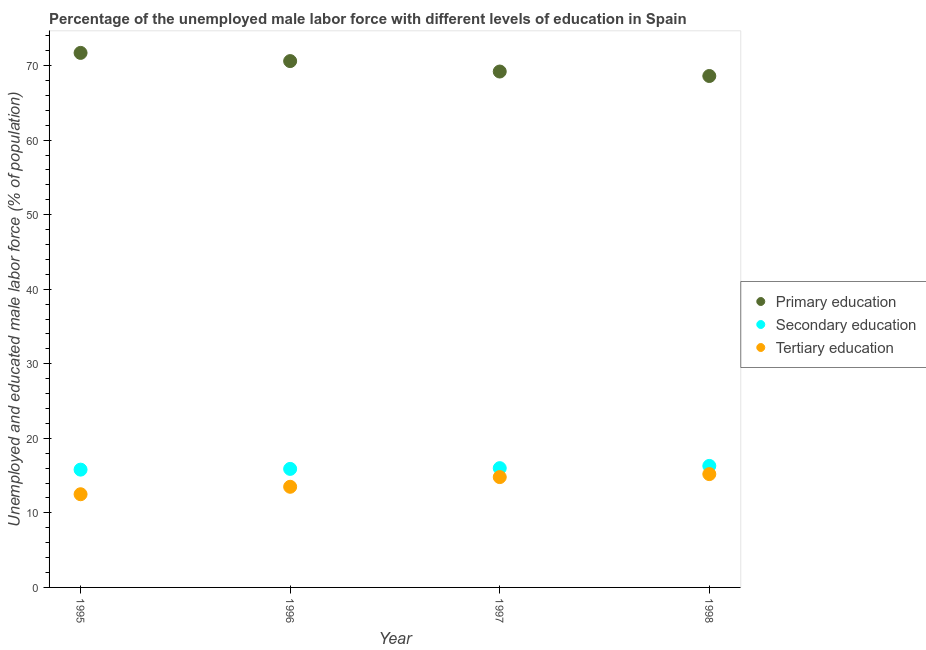How many different coloured dotlines are there?
Your response must be concise. 3. Is the number of dotlines equal to the number of legend labels?
Provide a short and direct response. Yes. What is the percentage of male labor force who received secondary education in 1996?
Give a very brief answer. 15.9. Across all years, what is the maximum percentage of male labor force who received primary education?
Give a very brief answer. 71.7. Across all years, what is the minimum percentage of male labor force who received secondary education?
Provide a succinct answer. 15.8. In which year was the percentage of male labor force who received secondary education maximum?
Provide a short and direct response. 1998. In which year was the percentage of male labor force who received primary education minimum?
Ensure brevity in your answer.  1998. What is the total percentage of male labor force who received tertiary education in the graph?
Keep it short and to the point. 56. What is the difference between the percentage of male labor force who received secondary education in 1996 and that in 1998?
Your answer should be very brief. -0.4. What is the difference between the percentage of male labor force who received tertiary education in 1997 and the percentage of male labor force who received secondary education in 1996?
Give a very brief answer. -1.1. What is the average percentage of male labor force who received secondary education per year?
Your answer should be compact. 16. In the year 1997, what is the difference between the percentage of male labor force who received primary education and percentage of male labor force who received secondary education?
Keep it short and to the point. 53.2. In how many years, is the percentage of male labor force who received primary education greater than 28 %?
Offer a very short reply. 4. What is the ratio of the percentage of male labor force who received primary education in 1995 to that in 1998?
Your response must be concise. 1.05. Is the percentage of male labor force who received secondary education in 1997 less than that in 1998?
Ensure brevity in your answer.  Yes. What is the difference between the highest and the second highest percentage of male labor force who received primary education?
Your response must be concise. 1.1. What is the difference between the highest and the lowest percentage of male labor force who received tertiary education?
Your answer should be very brief. 2.7. In how many years, is the percentage of male labor force who received tertiary education greater than the average percentage of male labor force who received tertiary education taken over all years?
Offer a terse response. 2. Is it the case that in every year, the sum of the percentage of male labor force who received primary education and percentage of male labor force who received secondary education is greater than the percentage of male labor force who received tertiary education?
Make the answer very short. Yes. Does the percentage of male labor force who received tertiary education monotonically increase over the years?
Ensure brevity in your answer.  Yes. Are the values on the major ticks of Y-axis written in scientific E-notation?
Your answer should be compact. No. Does the graph contain grids?
Offer a terse response. No. How are the legend labels stacked?
Offer a terse response. Vertical. What is the title of the graph?
Keep it short and to the point. Percentage of the unemployed male labor force with different levels of education in Spain. Does "Other sectors" appear as one of the legend labels in the graph?
Provide a short and direct response. No. What is the label or title of the Y-axis?
Make the answer very short. Unemployed and educated male labor force (% of population). What is the Unemployed and educated male labor force (% of population) of Primary education in 1995?
Provide a short and direct response. 71.7. What is the Unemployed and educated male labor force (% of population) in Secondary education in 1995?
Your answer should be compact. 15.8. What is the Unemployed and educated male labor force (% of population) in Primary education in 1996?
Your answer should be compact. 70.6. What is the Unemployed and educated male labor force (% of population) in Secondary education in 1996?
Your answer should be very brief. 15.9. What is the Unemployed and educated male labor force (% of population) in Primary education in 1997?
Ensure brevity in your answer.  69.2. What is the Unemployed and educated male labor force (% of population) in Secondary education in 1997?
Ensure brevity in your answer.  16. What is the Unemployed and educated male labor force (% of population) of Tertiary education in 1997?
Your answer should be very brief. 14.8. What is the Unemployed and educated male labor force (% of population) of Primary education in 1998?
Ensure brevity in your answer.  68.6. What is the Unemployed and educated male labor force (% of population) in Secondary education in 1998?
Make the answer very short. 16.3. What is the Unemployed and educated male labor force (% of population) in Tertiary education in 1998?
Offer a very short reply. 15.2. Across all years, what is the maximum Unemployed and educated male labor force (% of population) of Primary education?
Ensure brevity in your answer.  71.7. Across all years, what is the maximum Unemployed and educated male labor force (% of population) in Secondary education?
Your answer should be compact. 16.3. Across all years, what is the maximum Unemployed and educated male labor force (% of population) of Tertiary education?
Your response must be concise. 15.2. Across all years, what is the minimum Unemployed and educated male labor force (% of population) in Primary education?
Provide a short and direct response. 68.6. Across all years, what is the minimum Unemployed and educated male labor force (% of population) in Secondary education?
Keep it short and to the point. 15.8. Across all years, what is the minimum Unemployed and educated male labor force (% of population) of Tertiary education?
Your answer should be compact. 12.5. What is the total Unemployed and educated male labor force (% of population) of Primary education in the graph?
Offer a terse response. 280.1. What is the total Unemployed and educated male labor force (% of population) in Tertiary education in the graph?
Make the answer very short. 56. What is the difference between the Unemployed and educated male labor force (% of population) in Primary education in 1995 and that in 1996?
Keep it short and to the point. 1.1. What is the difference between the Unemployed and educated male labor force (% of population) of Primary education in 1995 and that in 1997?
Offer a terse response. 2.5. What is the difference between the Unemployed and educated male labor force (% of population) in Primary education in 1996 and that in 1998?
Give a very brief answer. 2. What is the difference between the Unemployed and educated male labor force (% of population) of Tertiary education in 1996 and that in 1998?
Make the answer very short. -1.7. What is the difference between the Unemployed and educated male labor force (% of population) of Tertiary education in 1997 and that in 1998?
Offer a terse response. -0.4. What is the difference between the Unemployed and educated male labor force (% of population) of Primary education in 1995 and the Unemployed and educated male labor force (% of population) of Secondary education in 1996?
Offer a terse response. 55.8. What is the difference between the Unemployed and educated male labor force (% of population) of Primary education in 1995 and the Unemployed and educated male labor force (% of population) of Tertiary education in 1996?
Provide a succinct answer. 58.2. What is the difference between the Unemployed and educated male labor force (% of population) of Primary education in 1995 and the Unemployed and educated male labor force (% of population) of Secondary education in 1997?
Make the answer very short. 55.7. What is the difference between the Unemployed and educated male labor force (% of population) of Primary education in 1995 and the Unemployed and educated male labor force (% of population) of Tertiary education in 1997?
Provide a short and direct response. 56.9. What is the difference between the Unemployed and educated male labor force (% of population) in Secondary education in 1995 and the Unemployed and educated male labor force (% of population) in Tertiary education in 1997?
Offer a terse response. 1. What is the difference between the Unemployed and educated male labor force (% of population) of Primary education in 1995 and the Unemployed and educated male labor force (% of population) of Secondary education in 1998?
Give a very brief answer. 55.4. What is the difference between the Unemployed and educated male labor force (% of population) in Primary education in 1995 and the Unemployed and educated male labor force (% of population) in Tertiary education in 1998?
Make the answer very short. 56.5. What is the difference between the Unemployed and educated male labor force (% of population) of Primary education in 1996 and the Unemployed and educated male labor force (% of population) of Secondary education in 1997?
Ensure brevity in your answer.  54.6. What is the difference between the Unemployed and educated male labor force (% of population) in Primary education in 1996 and the Unemployed and educated male labor force (% of population) in Tertiary education in 1997?
Your answer should be compact. 55.8. What is the difference between the Unemployed and educated male labor force (% of population) in Secondary education in 1996 and the Unemployed and educated male labor force (% of population) in Tertiary education in 1997?
Provide a short and direct response. 1.1. What is the difference between the Unemployed and educated male labor force (% of population) in Primary education in 1996 and the Unemployed and educated male labor force (% of population) in Secondary education in 1998?
Offer a very short reply. 54.3. What is the difference between the Unemployed and educated male labor force (% of population) of Primary education in 1996 and the Unemployed and educated male labor force (% of population) of Tertiary education in 1998?
Make the answer very short. 55.4. What is the difference between the Unemployed and educated male labor force (% of population) of Primary education in 1997 and the Unemployed and educated male labor force (% of population) of Secondary education in 1998?
Your answer should be compact. 52.9. What is the difference between the Unemployed and educated male labor force (% of population) in Primary education in 1997 and the Unemployed and educated male labor force (% of population) in Tertiary education in 1998?
Provide a short and direct response. 54. What is the difference between the Unemployed and educated male labor force (% of population) in Secondary education in 1997 and the Unemployed and educated male labor force (% of population) in Tertiary education in 1998?
Your answer should be compact. 0.8. What is the average Unemployed and educated male labor force (% of population) of Primary education per year?
Give a very brief answer. 70.03. What is the average Unemployed and educated male labor force (% of population) of Tertiary education per year?
Make the answer very short. 14. In the year 1995, what is the difference between the Unemployed and educated male labor force (% of population) of Primary education and Unemployed and educated male labor force (% of population) of Secondary education?
Offer a very short reply. 55.9. In the year 1995, what is the difference between the Unemployed and educated male labor force (% of population) of Primary education and Unemployed and educated male labor force (% of population) of Tertiary education?
Make the answer very short. 59.2. In the year 1996, what is the difference between the Unemployed and educated male labor force (% of population) of Primary education and Unemployed and educated male labor force (% of population) of Secondary education?
Your answer should be very brief. 54.7. In the year 1996, what is the difference between the Unemployed and educated male labor force (% of population) of Primary education and Unemployed and educated male labor force (% of population) of Tertiary education?
Your response must be concise. 57.1. In the year 1996, what is the difference between the Unemployed and educated male labor force (% of population) of Secondary education and Unemployed and educated male labor force (% of population) of Tertiary education?
Your answer should be compact. 2.4. In the year 1997, what is the difference between the Unemployed and educated male labor force (% of population) in Primary education and Unemployed and educated male labor force (% of population) in Secondary education?
Your response must be concise. 53.2. In the year 1997, what is the difference between the Unemployed and educated male labor force (% of population) of Primary education and Unemployed and educated male labor force (% of population) of Tertiary education?
Make the answer very short. 54.4. In the year 1998, what is the difference between the Unemployed and educated male labor force (% of population) in Primary education and Unemployed and educated male labor force (% of population) in Secondary education?
Your answer should be compact. 52.3. In the year 1998, what is the difference between the Unemployed and educated male labor force (% of population) in Primary education and Unemployed and educated male labor force (% of population) in Tertiary education?
Offer a very short reply. 53.4. In the year 1998, what is the difference between the Unemployed and educated male labor force (% of population) in Secondary education and Unemployed and educated male labor force (% of population) in Tertiary education?
Offer a very short reply. 1.1. What is the ratio of the Unemployed and educated male labor force (% of population) in Primary education in 1995 to that in 1996?
Keep it short and to the point. 1.02. What is the ratio of the Unemployed and educated male labor force (% of population) in Tertiary education in 1995 to that in 1996?
Provide a succinct answer. 0.93. What is the ratio of the Unemployed and educated male labor force (% of population) of Primary education in 1995 to that in 1997?
Keep it short and to the point. 1.04. What is the ratio of the Unemployed and educated male labor force (% of population) in Secondary education in 1995 to that in 1997?
Your response must be concise. 0.99. What is the ratio of the Unemployed and educated male labor force (% of population) of Tertiary education in 1995 to that in 1997?
Give a very brief answer. 0.84. What is the ratio of the Unemployed and educated male labor force (% of population) of Primary education in 1995 to that in 1998?
Your response must be concise. 1.05. What is the ratio of the Unemployed and educated male labor force (% of population) of Secondary education in 1995 to that in 1998?
Ensure brevity in your answer.  0.97. What is the ratio of the Unemployed and educated male labor force (% of population) in Tertiary education in 1995 to that in 1998?
Give a very brief answer. 0.82. What is the ratio of the Unemployed and educated male labor force (% of population) in Primary education in 1996 to that in 1997?
Make the answer very short. 1.02. What is the ratio of the Unemployed and educated male labor force (% of population) in Tertiary education in 1996 to that in 1997?
Provide a succinct answer. 0.91. What is the ratio of the Unemployed and educated male labor force (% of population) in Primary education in 1996 to that in 1998?
Provide a succinct answer. 1.03. What is the ratio of the Unemployed and educated male labor force (% of population) of Secondary education in 1996 to that in 1998?
Your answer should be compact. 0.98. What is the ratio of the Unemployed and educated male labor force (% of population) in Tertiary education in 1996 to that in 1998?
Give a very brief answer. 0.89. What is the ratio of the Unemployed and educated male labor force (% of population) of Primary education in 1997 to that in 1998?
Give a very brief answer. 1.01. What is the ratio of the Unemployed and educated male labor force (% of population) of Secondary education in 1997 to that in 1998?
Your answer should be compact. 0.98. What is the ratio of the Unemployed and educated male labor force (% of population) in Tertiary education in 1997 to that in 1998?
Your response must be concise. 0.97. What is the difference between the highest and the second highest Unemployed and educated male labor force (% of population) in Tertiary education?
Provide a succinct answer. 0.4. What is the difference between the highest and the lowest Unemployed and educated male labor force (% of population) of Tertiary education?
Give a very brief answer. 2.7. 